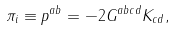<formula> <loc_0><loc_0><loc_500><loc_500>\pi _ { i } \equiv p ^ { a b } = - 2 G ^ { a b c d } K _ { c d } ,</formula> 